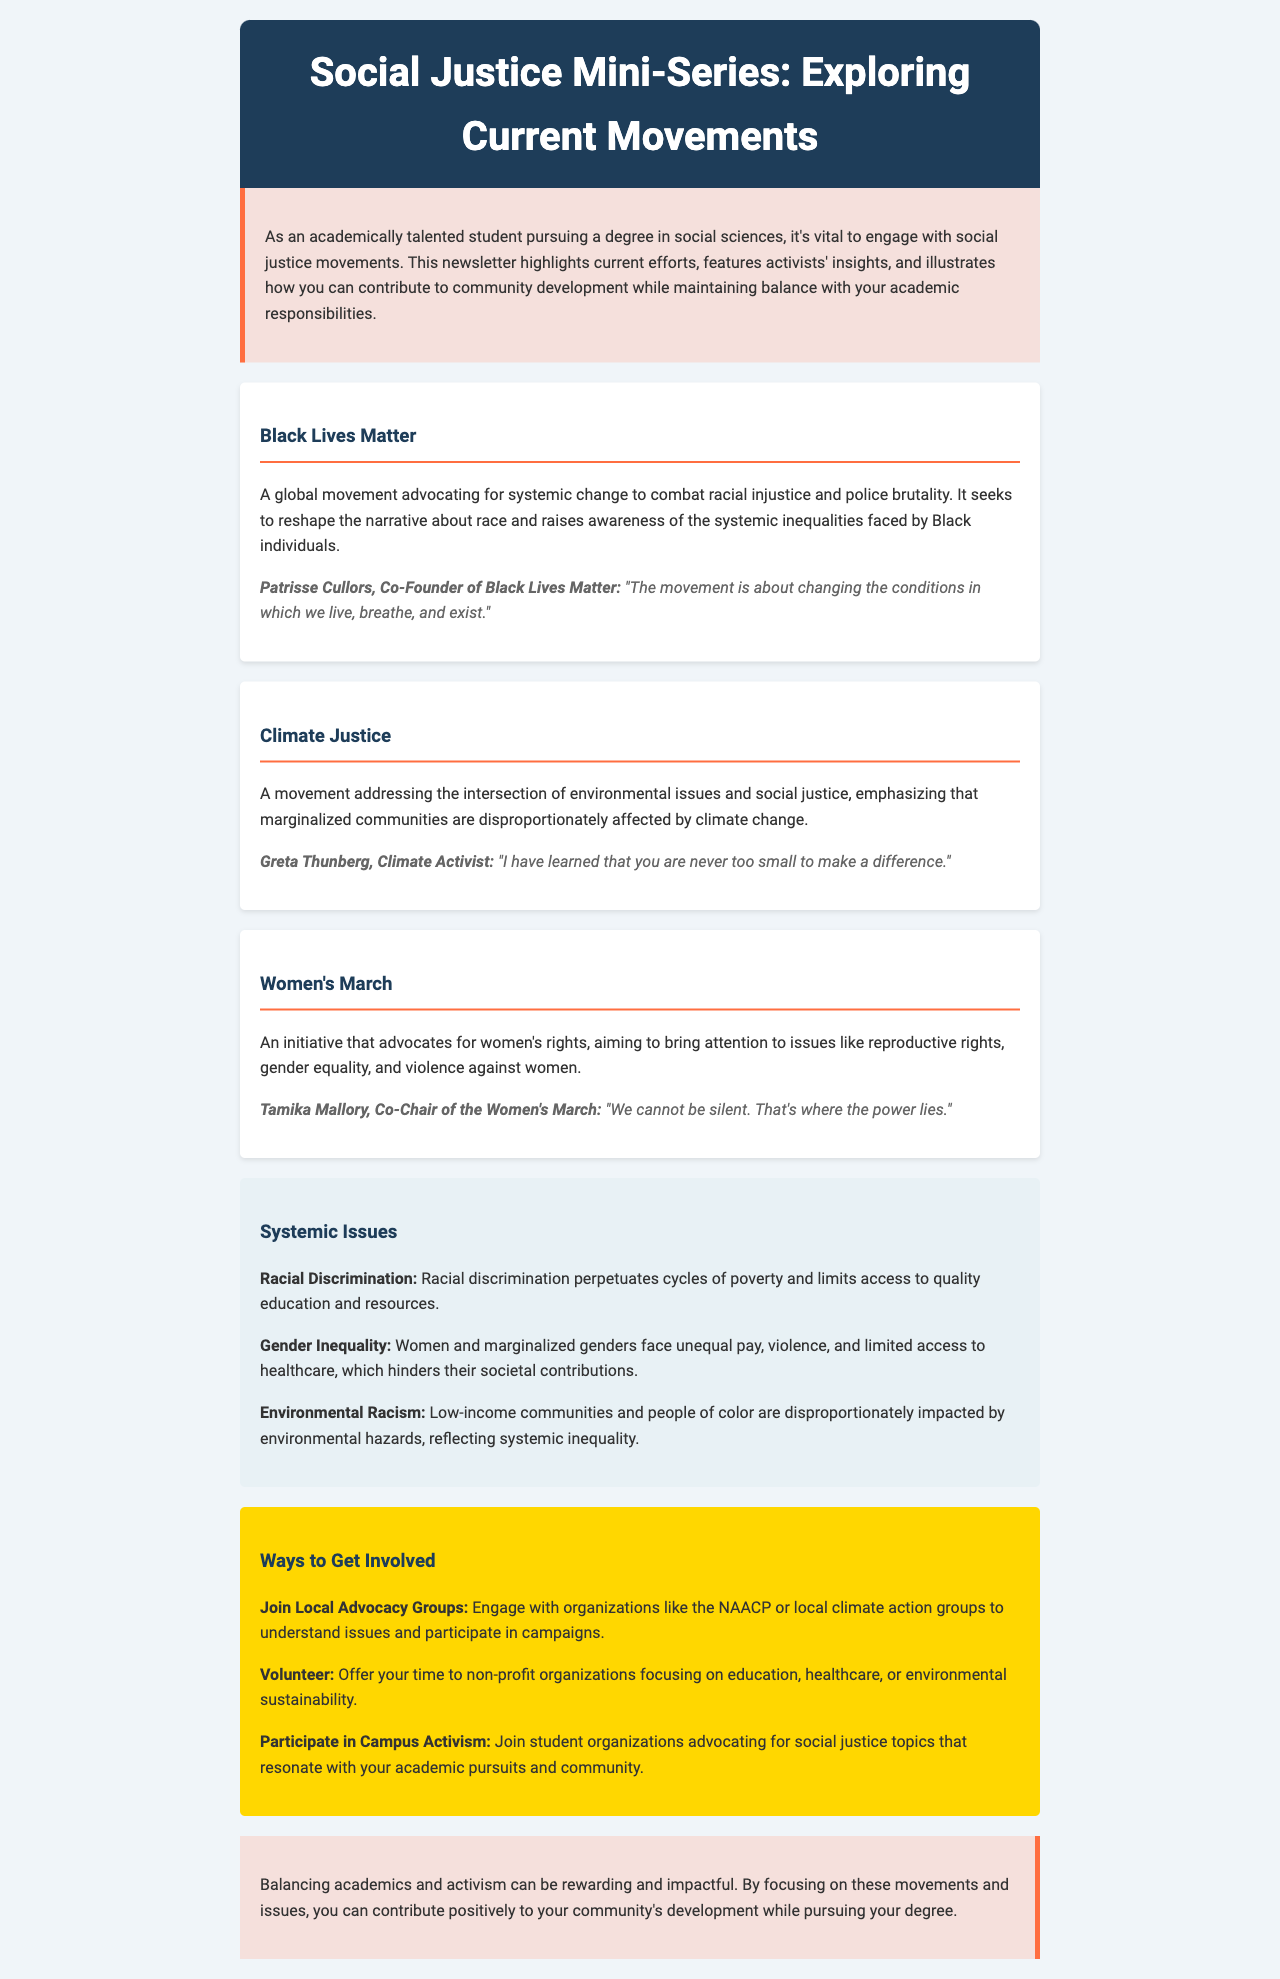What is the title of the newsletter? The title of the newsletter is presented in the header section.
Answer: Social Justice Mini-Series: Exploring Current Movements Who co-founded the Black Lives Matter movement? The document features an activist who co-founded the movement and their name is mentioned.
Answer: Patrisse Cullors What issue does the Women's March primarily focus on? The Women’s March is described in the newsletter, highlighting the topics it advocates for.
Answer: Women's rights What is one consequence of racial discrimination mentioned in the document? The document outlines the impact of racial discrimination as a systemic issue.
Answer: Cycles of poverty Which activist is associated with the Climate Justice movement? The newsletter includes a quote from an activist linked to climate issues.
Answer: Greta Thunberg How many movements are highlighted in the document? The number of movements discussed is indicated in the movements section.
Answer: Three What organization can you join to understand racial injustice better? The newsletter suggests local groups for involvement in advocacy.
Answer: NAACP What is a way to balance activism with academic responsibilities according to the closing section? The document advises on a manner to maintain balance between two pursuits.
Answer: Focus on movements and issues Which systemic issue involves the impact on low-income communities and people of color? The newsletter mentions a specific type of systemic issue affecting certain communities.
Answer: Environmental Racism 